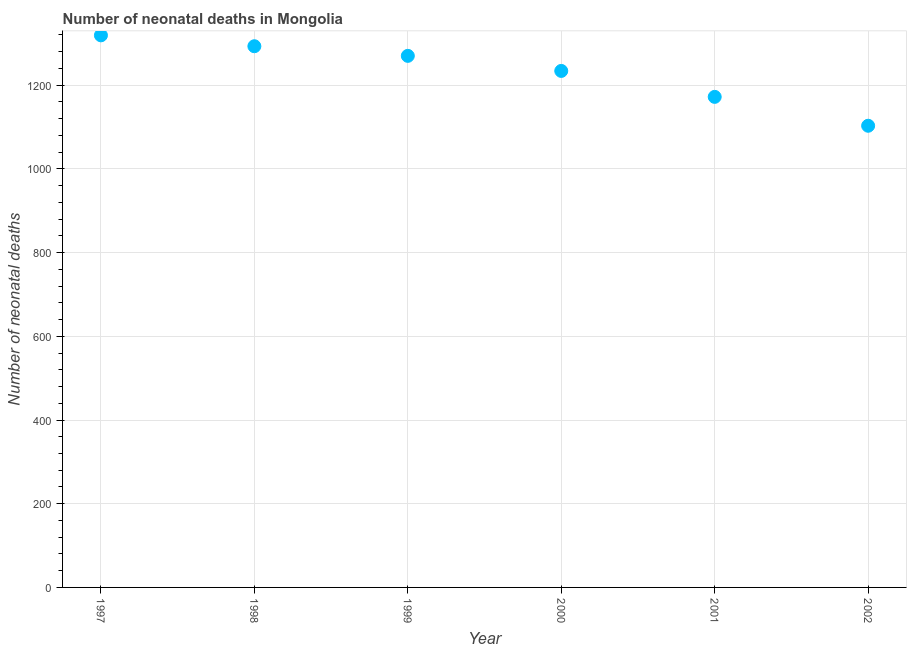What is the number of neonatal deaths in 2002?
Ensure brevity in your answer.  1103. Across all years, what is the maximum number of neonatal deaths?
Your answer should be compact. 1319. Across all years, what is the minimum number of neonatal deaths?
Offer a very short reply. 1103. In which year was the number of neonatal deaths minimum?
Ensure brevity in your answer.  2002. What is the sum of the number of neonatal deaths?
Keep it short and to the point. 7391. What is the difference between the number of neonatal deaths in 1997 and 2000?
Keep it short and to the point. 85. What is the average number of neonatal deaths per year?
Provide a succinct answer. 1231.83. What is the median number of neonatal deaths?
Your response must be concise. 1252. In how many years, is the number of neonatal deaths greater than 520 ?
Your response must be concise. 6. What is the ratio of the number of neonatal deaths in 1999 to that in 2000?
Your answer should be compact. 1.03. Is the difference between the number of neonatal deaths in 1997 and 1999 greater than the difference between any two years?
Offer a terse response. No. What is the difference between the highest and the lowest number of neonatal deaths?
Provide a succinct answer. 216. How many dotlines are there?
Provide a short and direct response. 1. How many years are there in the graph?
Offer a terse response. 6. What is the title of the graph?
Keep it short and to the point. Number of neonatal deaths in Mongolia. What is the label or title of the Y-axis?
Give a very brief answer. Number of neonatal deaths. What is the Number of neonatal deaths in 1997?
Provide a succinct answer. 1319. What is the Number of neonatal deaths in 1998?
Ensure brevity in your answer.  1293. What is the Number of neonatal deaths in 1999?
Give a very brief answer. 1270. What is the Number of neonatal deaths in 2000?
Ensure brevity in your answer.  1234. What is the Number of neonatal deaths in 2001?
Offer a terse response. 1172. What is the Number of neonatal deaths in 2002?
Ensure brevity in your answer.  1103. What is the difference between the Number of neonatal deaths in 1997 and 1999?
Provide a short and direct response. 49. What is the difference between the Number of neonatal deaths in 1997 and 2000?
Provide a succinct answer. 85. What is the difference between the Number of neonatal deaths in 1997 and 2001?
Offer a terse response. 147. What is the difference between the Number of neonatal deaths in 1997 and 2002?
Offer a very short reply. 216. What is the difference between the Number of neonatal deaths in 1998 and 2000?
Provide a succinct answer. 59. What is the difference between the Number of neonatal deaths in 1998 and 2001?
Give a very brief answer. 121. What is the difference between the Number of neonatal deaths in 1998 and 2002?
Offer a very short reply. 190. What is the difference between the Number of neonatal deaths in 1999 and 2000?
Offer a terse response. 36. What is the difference between the Number of neonatal deaths in 1999 and 2002?
Make the answer very short. 167. What is the difference between the Number of neonatal deaths in 2000 and 2001?
Offer a very short reply. 62. What is the difference between the Number of neonatal deaths in 2000 and 2002?
Offer a very short reply. 131. What is the ratio of the Number of neonatal deaths in 1997 to that in 1998?
Provide a succinct answer. 1.02. What is the ratio of the Number of neonatal deaths in 1997 to that in 1999?
Offer a very short reply. 1.04. What is the ratio of the Number of neonatal deaths in 1997 to that in 2000?
Provide a short and direct response. 1.07. What is the ratio of the Number of neonatal deaths in 1997 to that in 2001?
Your response must be concise. 1.12. What is the ratio of the Number of neonatal deaths in 1997 to that in 2002?
Your answer should be very brief. 1.2. What is the ratio of the Number of neonatal deaths in 1998 to that in 1999?
Keep it short and to the point. 1.02. What is the ratio of the Number of neonatal deaths in 1998 to that in 2000?
Your answer should be compact. 1.05. What is the ratio of the Number of neonatal deaths in 1998 to that in 2001?
Make the answer very short. 1.1. What is the ratio of the Number of neonatal deaths in 1998 to that in 2002?
Provide a short and direct response. 1.17. What is the ratio of the Number of neonatal deaths in 1999 to that in 2001?
Make the answer very short. 1.08. What is the ratio of the Number of neonatal deaths in 1999 to that in 2002?
Provide a short and direct response. 1.15. What is the ratio of the Number of neonatal deaths in 2000 to that in 2001?
Your answer should be very brief. 1.05. What is the ratio of the Number of neonatal deaths in 2000 to that in 2002?
Keep it short and to the point. 1.12. What is the ratio of the Number of neonatal deaths in 2001 to that in 2002?
Offer a very short reply. 1.06. 